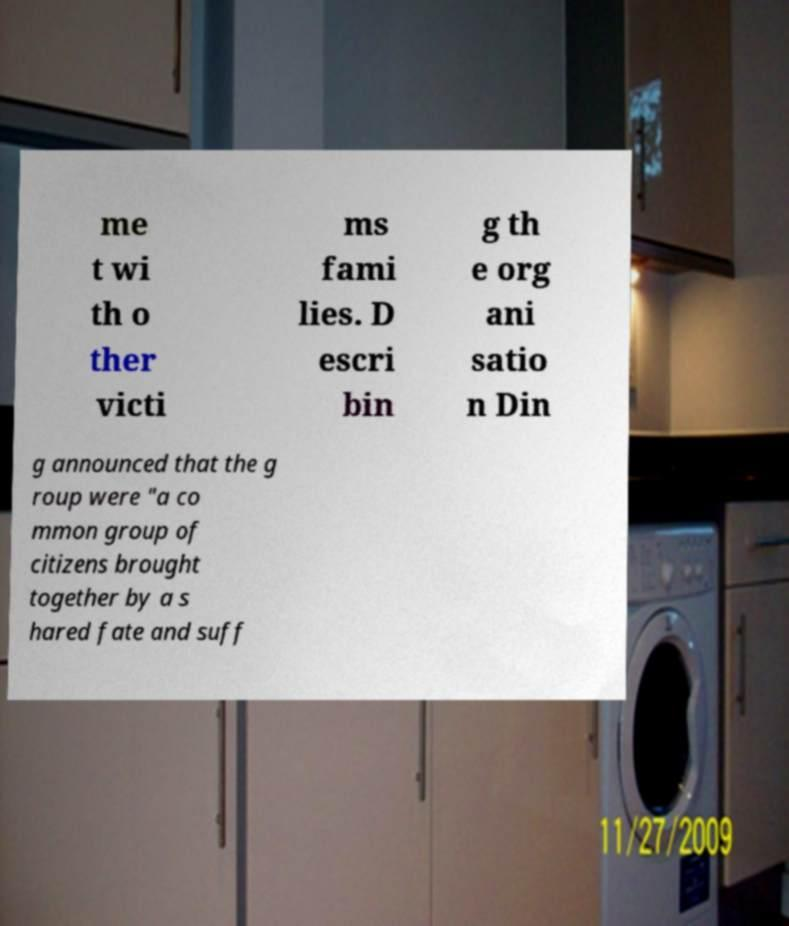Could you assist in decoding the text presented in this image and type it out clearly? me t wi th o ther victi ms fami lies. D escri bin g th e org ani satio n Din g announced that the g roup were "a co mmon group of citizens brought together by a s hared fate and suff 